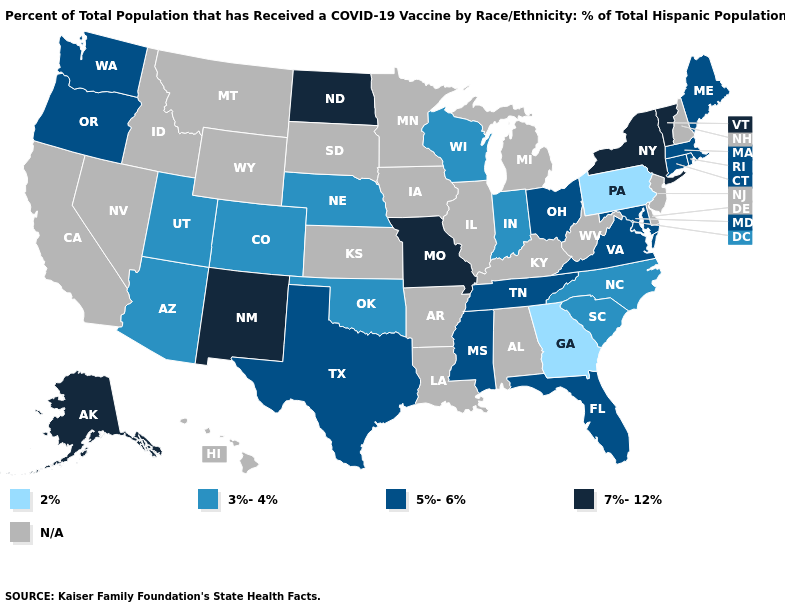How many symbols are there in the legend?
Short answer required. 5. What is the value of Iowa?
Write a very short answer. N/A. What is the value of Mississippi?
Answer briefly. 5%-6%. Among the states that border Rhode Island , which have the highest value?
Short answer required. Connecticut, Massachusetts. How many symbols are there in the legend?
Keep it brief. 5. What is the highest value in the West ?
Answer briefly. 7%-12%. Among the states that border Arkansas , does Oklahoma have the lowest value?
Keep it brief. Yes. Name the states that have a value in the range 2%?
Quick response, please. Georgia, Pennsylvania. Which states have the lowest value in the USA?
Quick response, please. Georgia, Pennsylvania. Does Pennsylvania have the lowest value in the USA?
Be succinct. Yes. Among the states that border Colorado , which have the lowest value?
Write a very short answer. Arizona, Nebraska, Oklahoma, Utah. Among the states that border Illinois , does Missouri have the highest value?
Short answer required. Yes. Among the states that border Illinois , does Missouri have the lowest value?
Be succinct. No. 